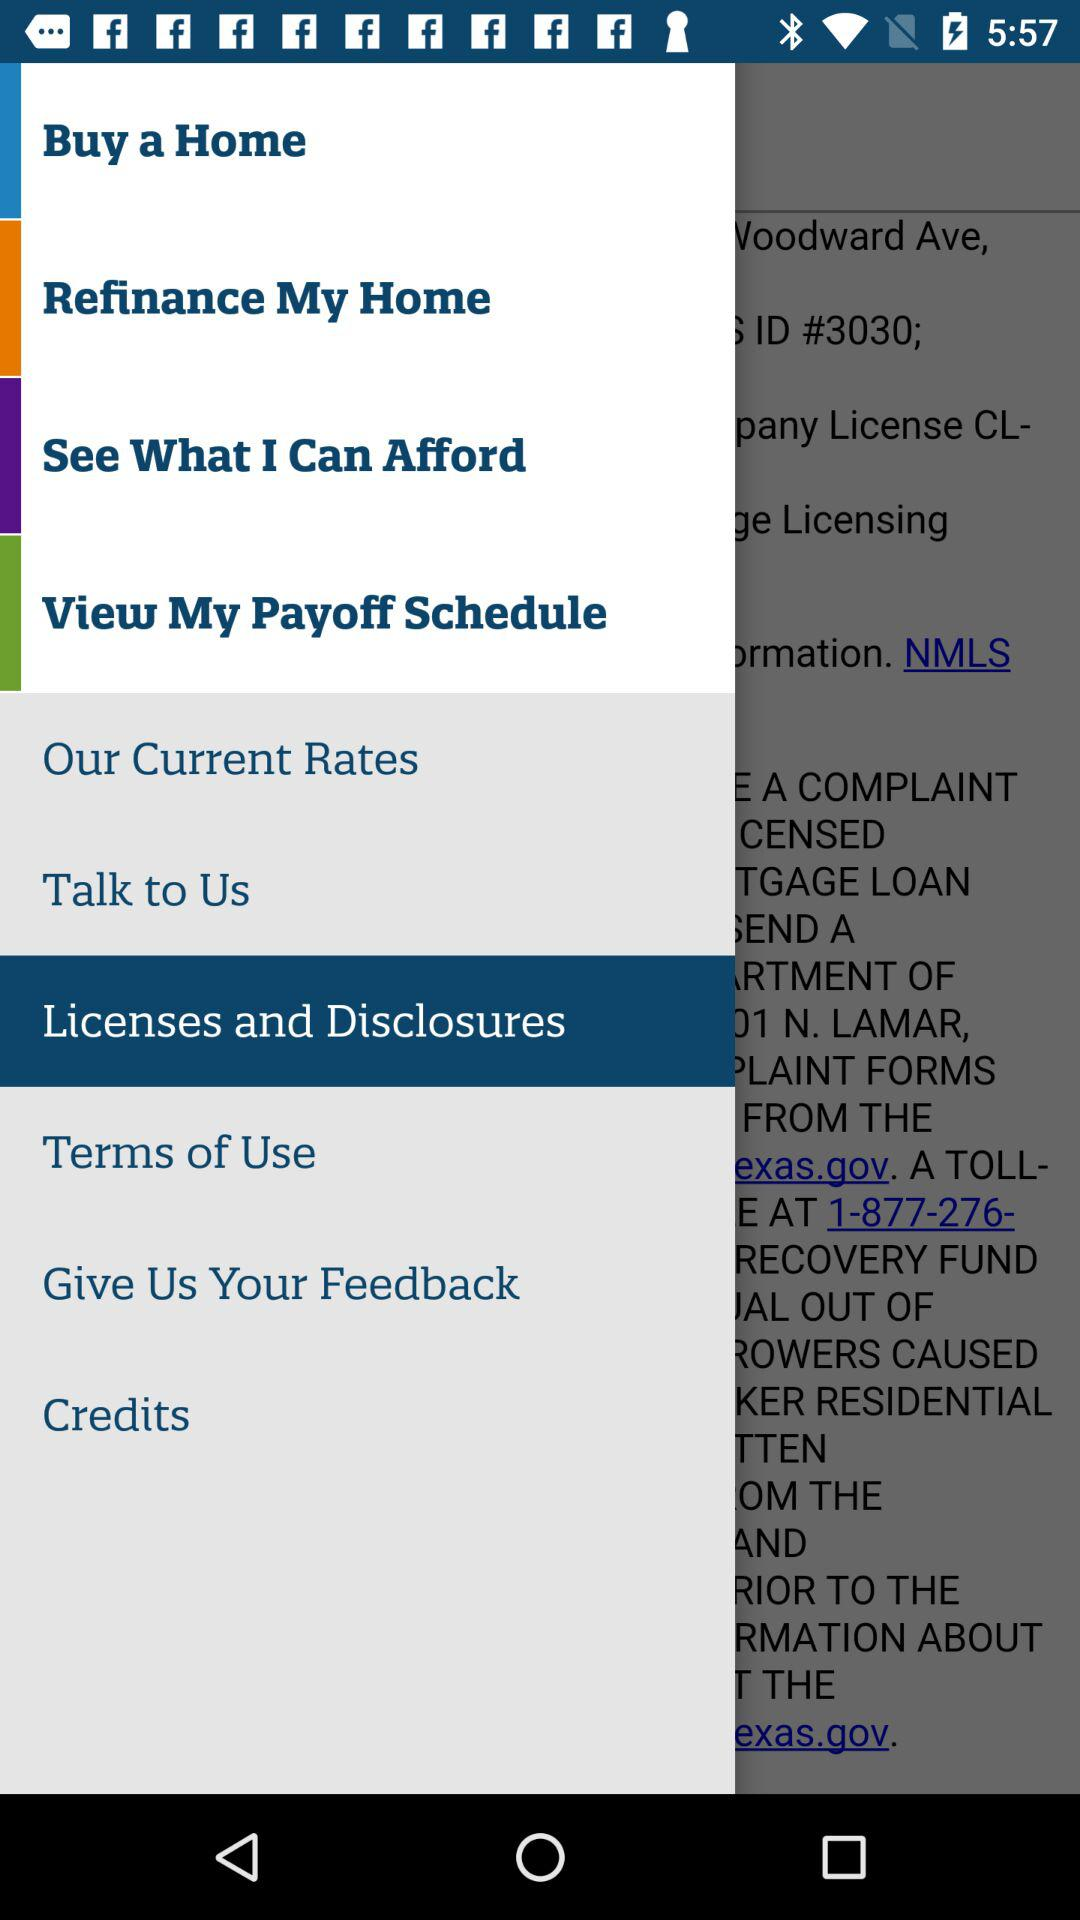Which option is selected? The selected option is "Licenses and Disclosures". 